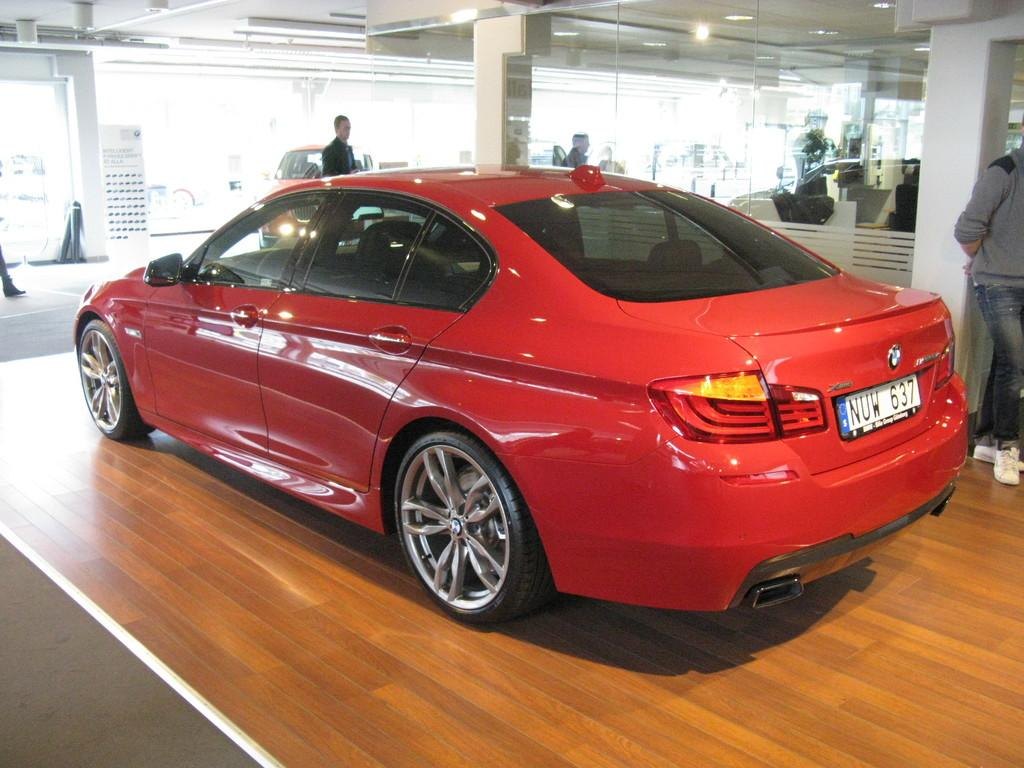What is the main subject in the center of the image? There is a car in the center of the image. What is the man on the right side of the image doing? The man is standing at a pillar on the right side of the image. What type of architectural feature can be seen in the background of the image? There is a glass wall in the background of the image. Can you describe the other person visible in the image? There is another man in the background of the image. What else can be seen in the background of the image? There is another car visible in the background of the image. What type of punishment is being administered to the rabbits in the image? There are no rabbits present in the image, so no punishment is being administered. 